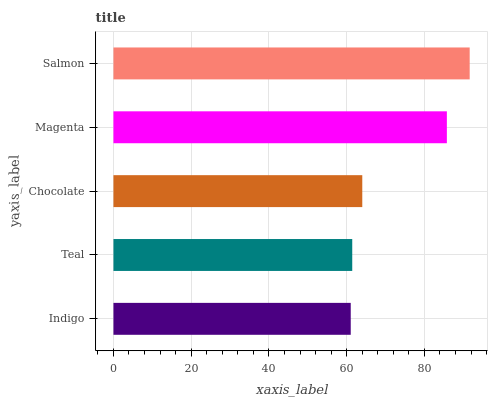Is Indigo the minimum?
Answer yes or no. Yes. Is Salmon the maximum?
Answer yes or no. Yes. Is Teal the minimum?
Answer yes or no. No. Is Teal the maximum?
Answer yes or no. No. Is Teal greater than Indigo?
Answer yes or no. Yes. Is Indigo less than Teal?
Answer yes or no. Yes. Is Indigo greater than Teal?
Answer yes or no. No. Is Teal less than Indigo?
Answer yes or no. No. Is Chocolate the high median?
Answer yes or no. Yes. Is Chocolate the low median?
Answer yes or no. Yes. Is Indigo the high median?
Answer yes or no. No. Is Magenta the low median?
Answer yes or no. No. 